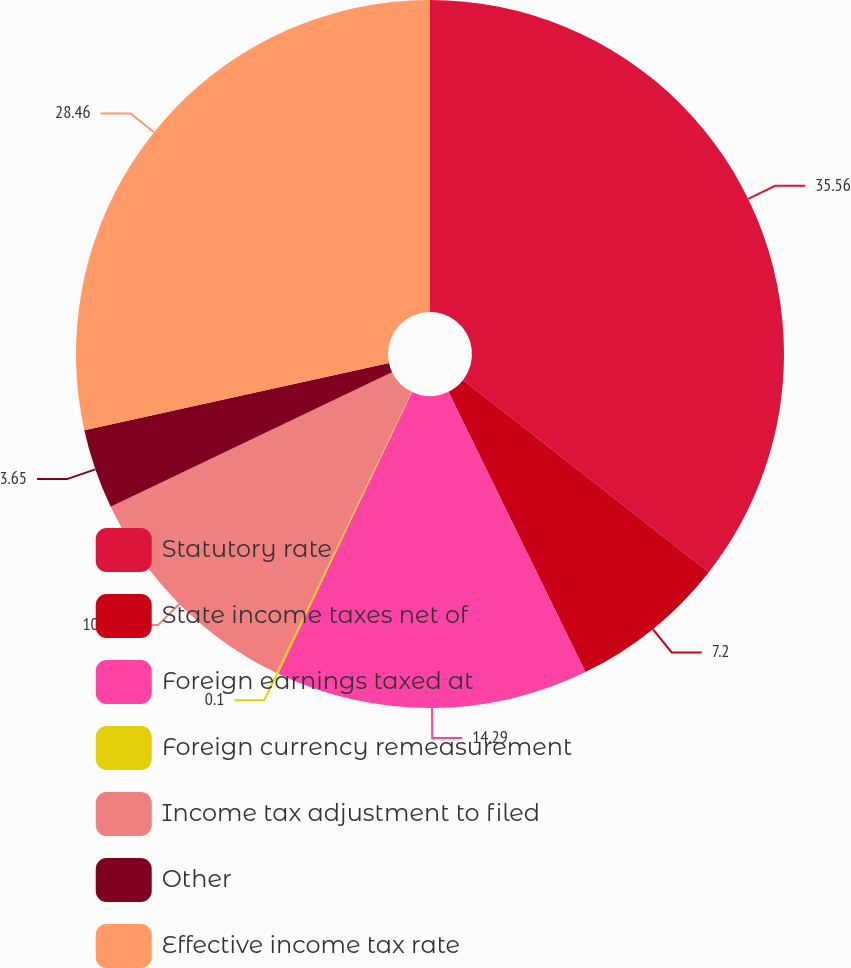Convert chart. <chart><loc_0><loc_0><loc_500><loc_500><pie_chart><fcel>Statutory rate<fcel>State income taxes net of<fcel>Foreign earnings taxed at<fcel>Foreign currency remeasurement<fcel>Income tax adjustment to filed<fcel>Other<fcel>Effective income tax rate<nl><fcel>35.57%<fcel>7.2%<fcel>14.29%<fcel>0.1%<fcel>10.74%<fcel>3.65%<fcel>28.46%<nl></chart> 